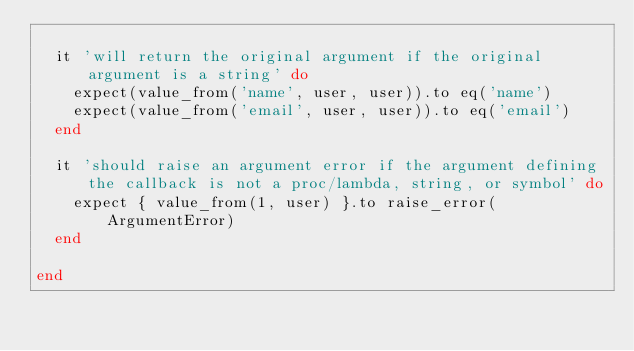<code> <loc_0><loc_0><loc_500><loc_500><_Ruby_>
  it 'will return the original argument if the original argument is a string' do
    expect(value_from('name', user, user)).to eq('name')
    expect(value_from('email', user, user)).to eq('email')
  end

  it 'should raise an argument error if the argument defining the callback is not a proc/lambda, string, or symbol' do
    expect { value_from(1, user) }.to raise_error(ArgumentError)
  end

end
</code> 